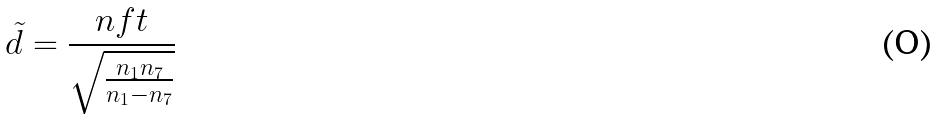<formula> <loc_0><loc_0><loc_500><loc_500>\tilde { d } = \frac { n f t } { \sqrt { \frac { n _ { 1 } n _ { 7 } } { n _ { 1 } - n _ { 7 } } } }</formula> 